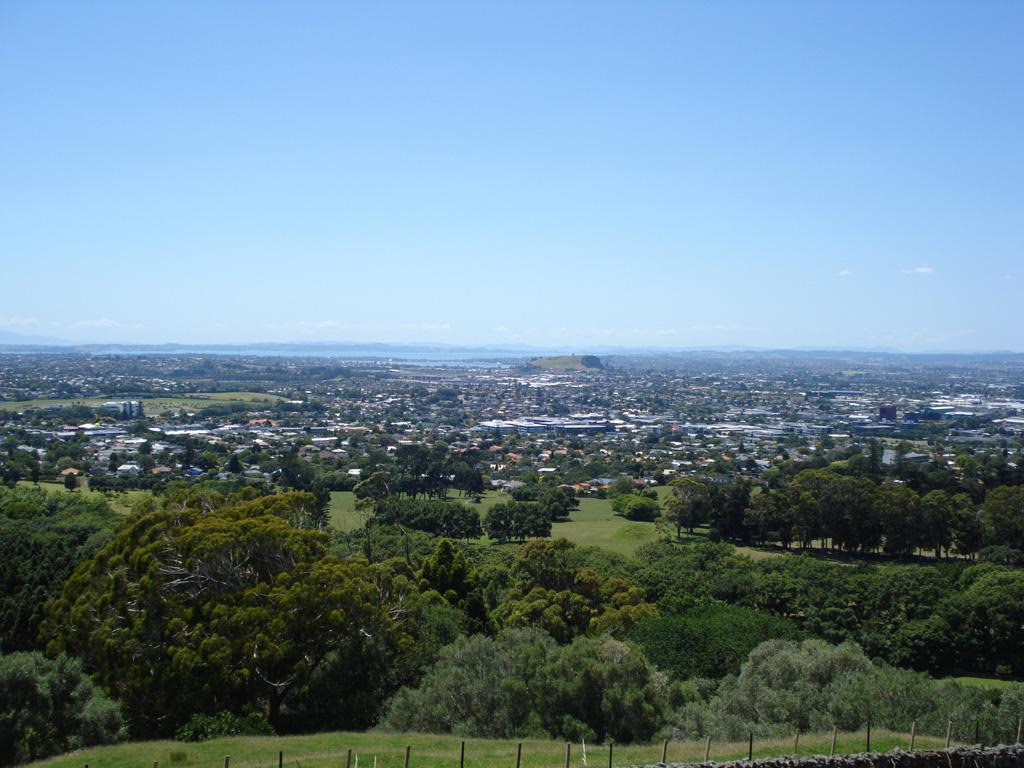What structures can be seen in the image? There are poles in the image. What type of natural environment is visible in the background of the image? There are trees, mountains, and the sky visible in the background of the image. What type of man-made structures can be seen in the background of the image? There are buildings in the background of the image. What type of air is being released from the poles in the image? There is no indication in the image that the poles are releasing any air. 